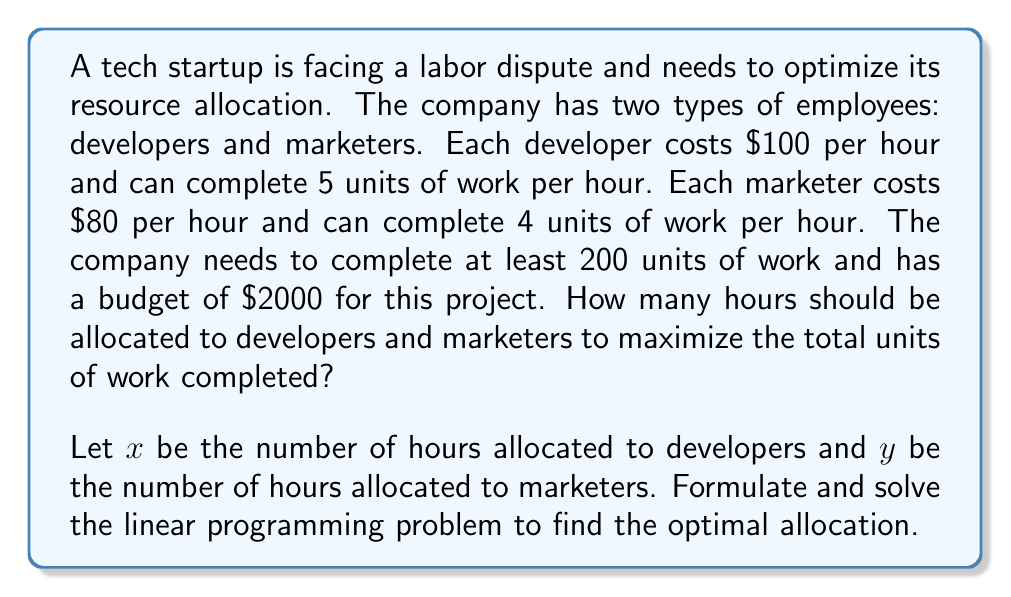What is the answer to this math problem? To solve this problem, we'll follow these steps:

1. Define the objective function:
   We want to maximize the total units of work completed.
   $$\text{Maximize: } Z = 5x + 4y$$

2. Identify the constraints:
   a) Budget constraint: $100x + 80y \leq 2000$
   b) Minimum work requirement: $5x + 4y \geq 200$
   c) Non-negativity constraints: $x \geq 0, y \geq 0$

3. Graph the constraints:
   [asy]
   import graph;
   size(200);
   xaxis("x (Developer hours)", 0, 25);
   yaxis("y (Marketer hours)", 0, 30);
   draw((0,25)--(20,0), blue);
   draw((0,50)--(40,0), red);
   fill((0,25)--(20,0)--(40,0)--(0,50)--cycle, palegreen);
   label("Feasible Region", (10,15));
   label("Budget", (15,5), blue);
   label("Work Requirement", (25,5), red);
   [/asy]

4. Identify the corner points of the feasible region:
   (0, 25), (20, 0), and the intersection point of the two constraint lines.

5. Find the intersection point by solving the system of equations:
   $$100x + 80y = 2000$$
   $$5x + 4y = 200$$

   Solving this system gives us: $x = 16, y = 10$

6. Evaluate the objective function at each corner point:
   (0, 25): $Z = 5(0) + 4(25) = 100$
   (20, 0): $Z = 5(20) + 4(0) = 100$
   (16, 10): $Z = 5(16) + 4(10) = 120$

7. The maximum value of Z occurs at (16, 10), which is our optimal solution.

Therefore, the optimal allocation is 16 hours for developers and 10 hours for marketers, resulting in a maximum of 120 units of work completed.
Answer: Developers: 16 hours, Marketers: 10 hours 